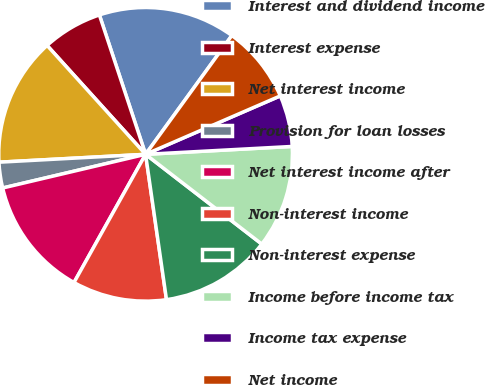Convert chart. <chart><loc_0><loc_0><loc_500><loc_500><pie_chart><fcel>Interest and dividend income<fcel>Interest expense<fcel>Net interest income<fcel>Provision for loan losses<fcel>Net interest income after<fcel>Non-interest income<fcel>Non-interest expense<fcel>Income before income tax<fcel>Income tax expense<fcel>Net income<nl><fcel>15.09%<fcel>6.61%<fcel>14.15%<fcel>2.83%<fcel>13.21%<fcel>10.38%<fcel>12.26%<fcel>11.32%<fcel>5.66%<fcel>8.49%<nl></chart> 